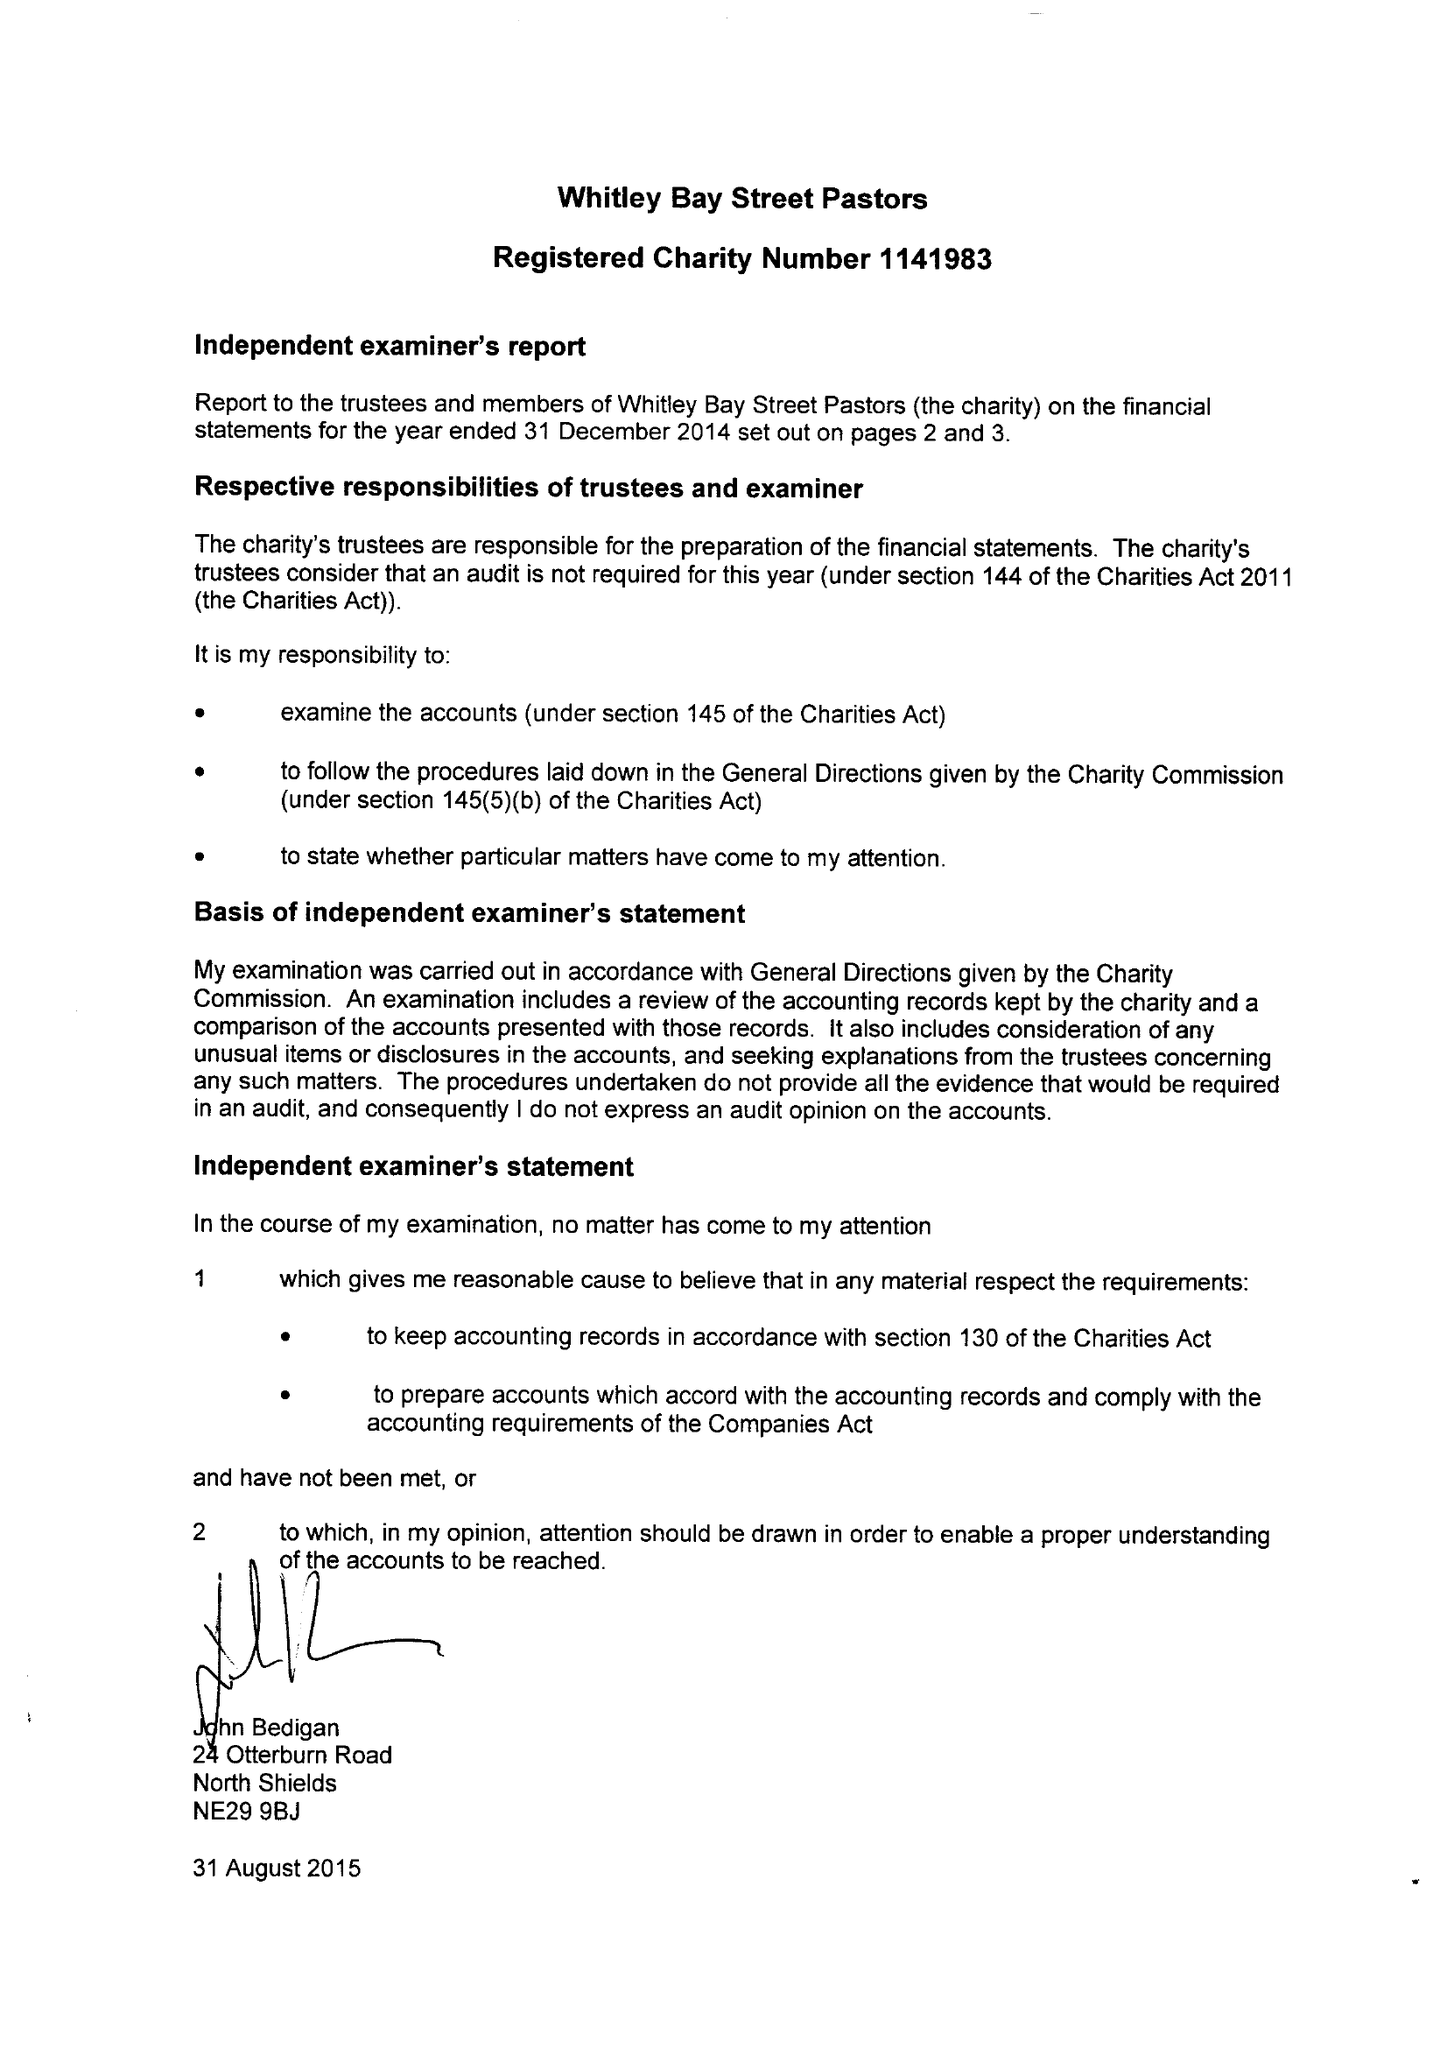What is the value for the charity_name?
Answer the question using a single word or phrase. Whitley Bay Street Pastors 